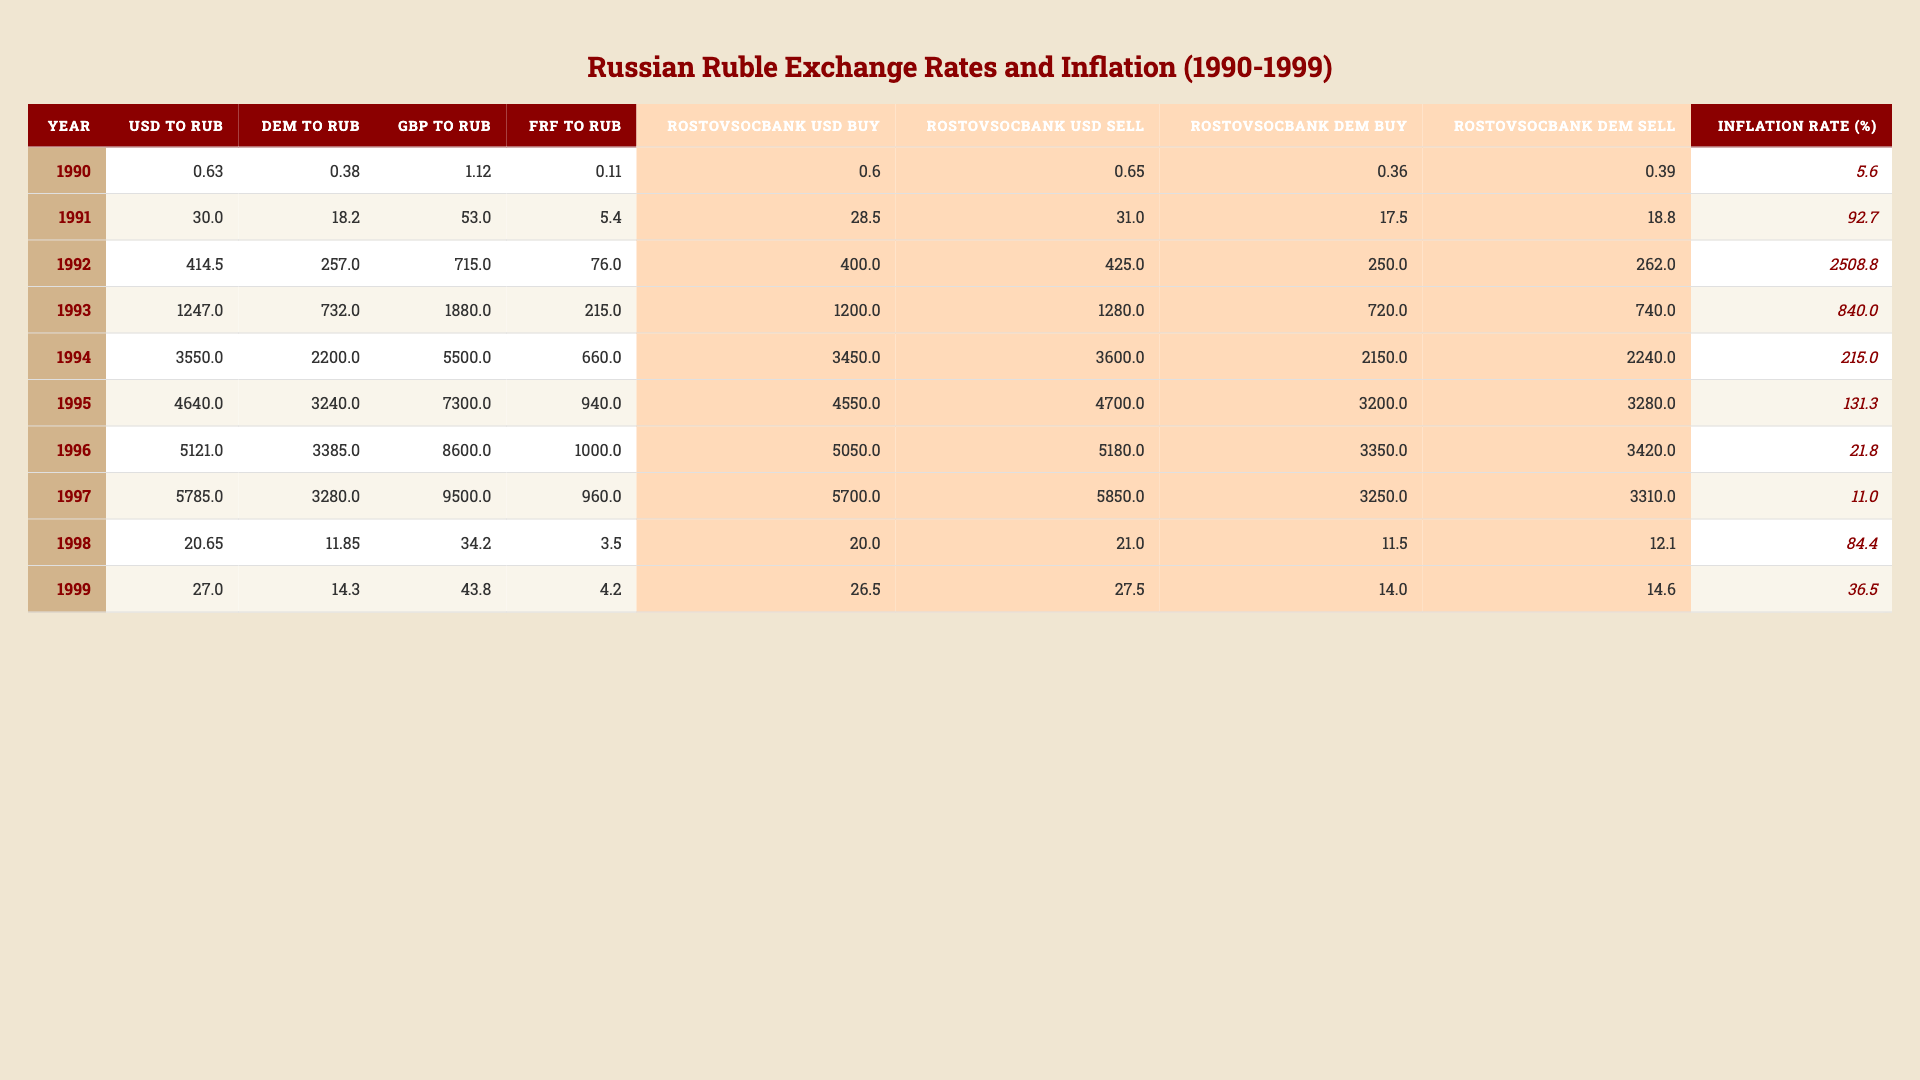What was the exchange rate of 1 USD to RUB in 1995? The table indicates that in 1995, the exchange rate for 1 USD to RUB was 4640.0.
Answer: 4640.0 What was the highest inflation rate recorded in the 1990s? Upon examining the inflation rates for each year, the highest rate was 2508.8 in 1992.
Answer: 2508.8 In which year did the Rostovsocbank sell USD at the price closest to 30 RUB? Looking at the "Rostovsocbank USD Sell" values, in 1991 the value was 31.0, which is closest to 30 RUB.
Answer: 1991 What was the percentage increase in the USD to RUB exchange rate from 1993 to 1994? The rate in 1993 was 1247.0 and in 1994 it was 3550.0. The increase is calculated as (3550.0 - 1247.0) / 1247.0 * 100, which equals approximately 184.5%.
Answer: 184.5% Was the DEM to RUB exchange rate always higher than the GBP to RUB exchange rate during the 1990s? By comparing the two columns for each year, it is evident that this statement is false as in 1999, 11.85 for DEM is less than 34.2 for GBP.
Answer: No What was the average exchange rate of the USD to RUB for the years 1990 to 1994? Adding the rates for these years (0.63 + 30.0 + 414.5 + 1247.0 + 3550.0) gives 4242.83, which when divided by 5 (the total number of years) results in an average of 848.566.
Answer: 848.566 How much did the Rostovsocbank's buy price for DEM change from 1992 to 1997? The buy price for DEM in 1992 was 250.0 and in 1997 it was 3280.0. The change is 3280.0 - 250.0 = 3030.0.
Answer: 3030.0 In what year did the GBP to RUB exchange rate surpass 5000 RUB? Looking through the GBP to RUB values, we see it first surpassed 5000 RUB in 1994, where it recorded 5500.0.
Answer: 1994 What is the difference between the BUY and SELL prices for USD in 1999? The Rostovsocbank USD Buy price in 1999 was 20.0 and the Sell price was 21.0. The difference is calculated as 21.0 - 20.0 = 1.0.
Answer: 1.0 What can be inferred about the trend of the USD to RUB exchange rate from 1990 to 1999? Observing the data, it reveals a clear increasing trend in the USD to RUB exchange rate over the years, indicating a depreciation of the ruble against the dollar.
Answer: The trend is increasing 